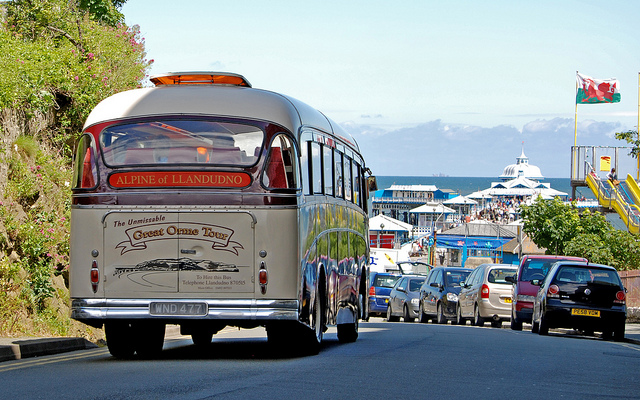Please extract the text content from this image. ALPINE of LLANDUDNO Great Orme WND 7477 Tour Unmissable The 